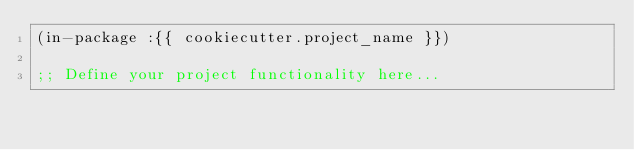<code> <loc_0><loc_0><loc_500><loc_500><_Lisp_>(in-package :{{ cookiecutter.project_name }})

;; Define your project functionality here...
</code> 